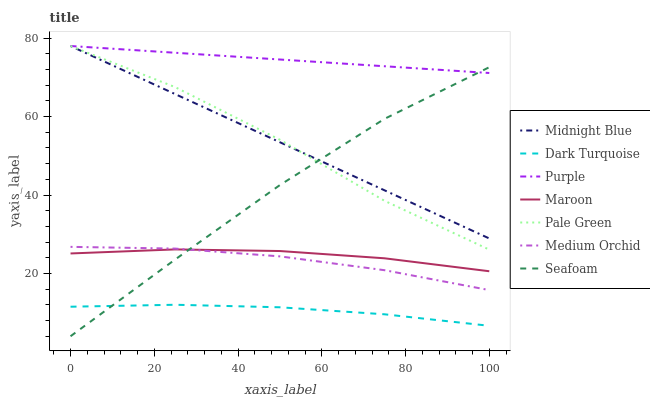Does Dark Turquoise have the minimum area under the curve?
Answer yes or no. Yes. Does Purple have the maximum area under the curve?
Answer yes or no. Yes. Does Purple have the minimum area under the curve?
Answer yes or no. No. Does Dark Turquoise have the maximum area under the curve?
Answer yes or no. No. Is Purple the smoothest?
Answer yes or no. Yes. Is Pale Green the roughest?
Answer yes or no. Yes. Is Dark Turquoise the smoothest?
Answer yes or no. No. Is Dark Turquoise the roughest?
Answer yes or no. No. Does Dark Turquoise have the lowest value?
Answer yes or no. No. Does Dark Turquoise have the highest value?
Answer yes or no. No. Is Medium Orchid less than Midnight Blue?
Answer yes or no. Yes. Is Maroon greater than Dark Turquoise?
Answer yes or no. Yes. Does Medium Orchid intersect Midnight Blue?
Answer yes or no. No. 